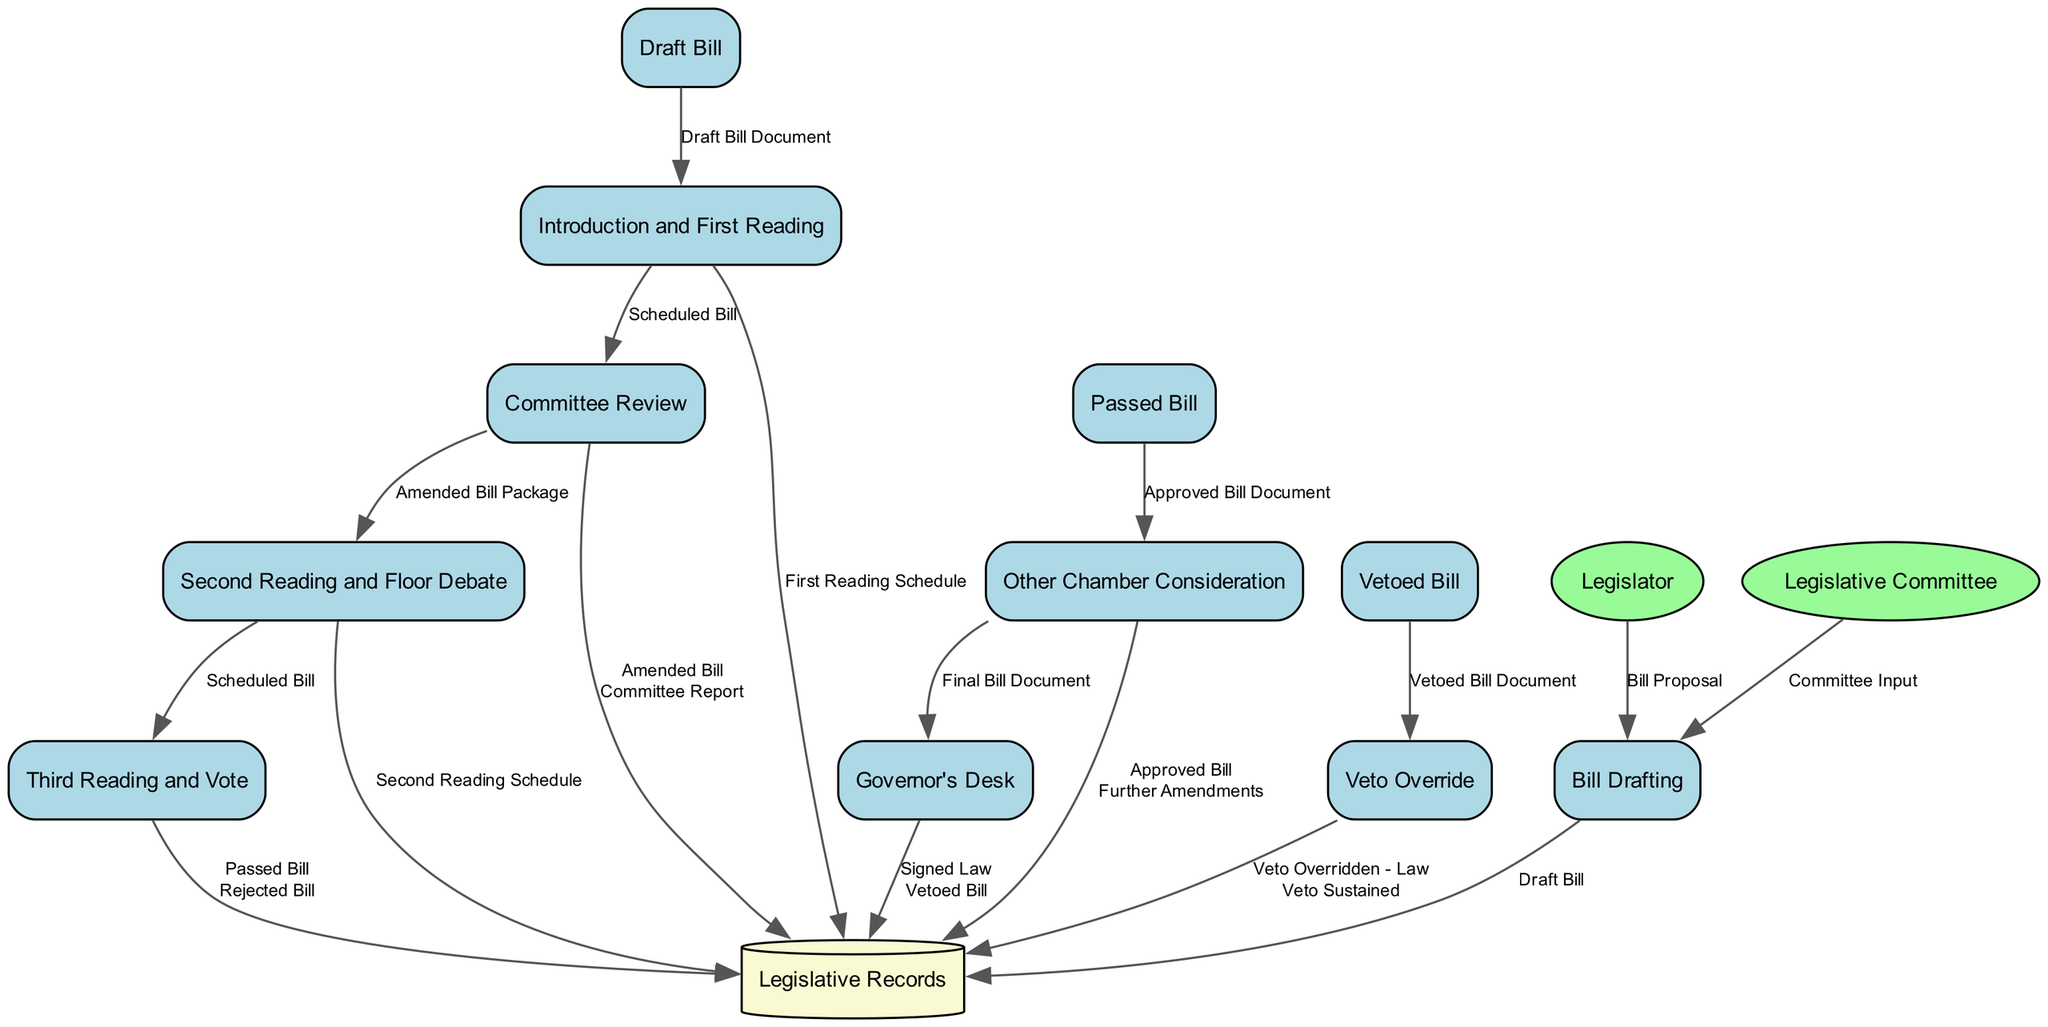What is the first process in the legislative flow? The diagram starts with "Bill Drafting," which is the first process in the flow of legislative bills.
Answer: Bill Drafting How many outputs does "Committee Review" produce? "Committee Review" produces two outputs: "Amended Bill" and "Committee Report." Therefore, the total outputs are two.
Answer: 2 What data is produced by the "Third Reading and Vote"? The "Third Reading and Vote" process has two potential outputs: "Passed Bill" and "Rejected Bill." This means it can produce either of these two outcomes.
Answer: Passed Bill, Rejected Bill Which process comes after "Second Reading and Floor Debate"? Following the "Second Reading and Floor Debate," the next process in the diagram is "Third Reading and Vote." Therefore, this is the sequence in the flow.
Answer: Third Reading and Vote What is the input to the "Governor's Desk"? The process "Governor's Desk" receives an input labeled "Approved Bill," which is the document being sent to the Governor for final approval or veto.
Answer: Approved Bill What happens if a bill is vetoed by the Governor? If a bill is vetoed by the Governor, the next process that may occur is "Veto Override," where the legislature can attempt to override the veto with a two-thirds majority vote.
Answer: Veto Override What is the final outcome if the "Governor's Desk" process results in a signed law? If the "Governor's Desk" process results in a signed law, it outputs "Signed Law." This marks the completion of the legislative process.
Answer: Signed Law How does a bill progress through the other chamber after passing in one chamber? After passing in one chamber, the bill is sent to "Other Chamber Consideration," where it follows similar steps (First Reading, Committee Review, Second Reading, and Third Reading).
Answer: Other Chamber Consideration What does the "Legislative Records" data store contain? The "Legislative Records" is a repository for all legislative documents, which includes Draft Bills, Amended Bills, Committee Reports, Passed Bills, and Signed Laws.
Answer: Legislative documents 